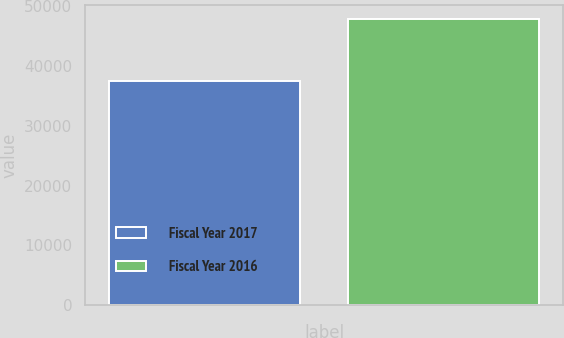Convert chart to OTSL. <chart><loc_0><loc_0><loc_500><loc_500><bar_chart><fcel>Fiscal Year 2017<fcel>Fiscal Year 2016<nl><fcel>37578<fcel>47834<nl></chart> 